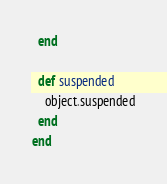Convert code to text. <code><loc_0><loc_0><loc_500><loc_500><_Ruby_>  end

  def suspended
    object.suspended
  end
end
</code> 